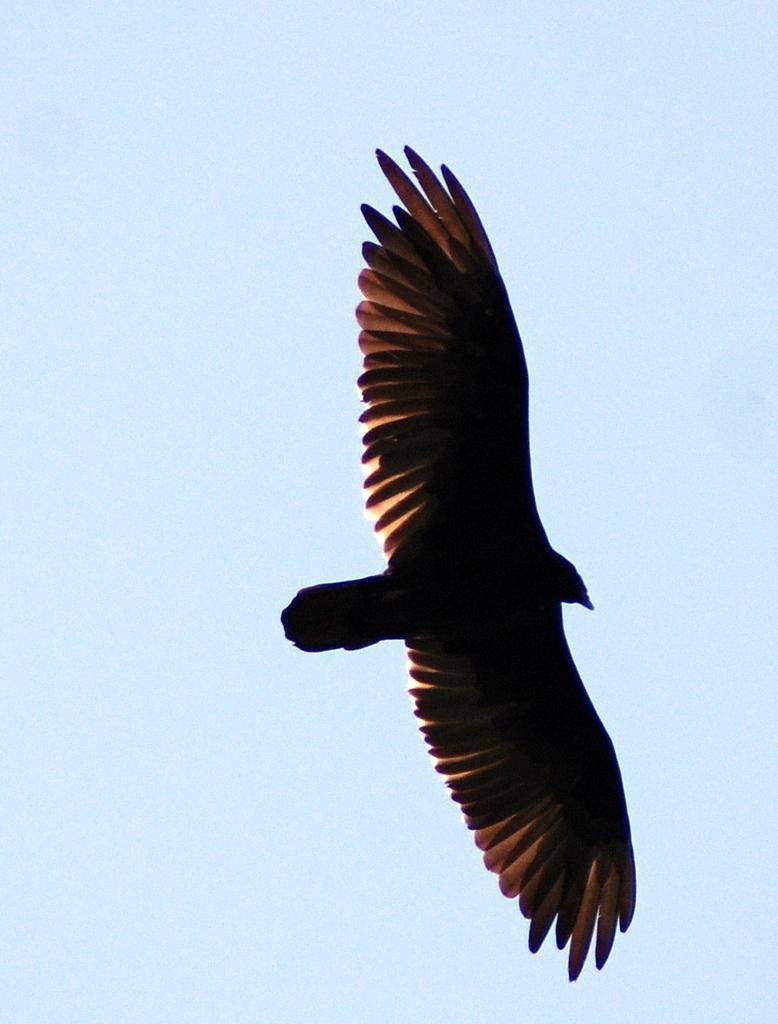What is the main subject of the image? The main subject of the image is a bird. What is the bird doing in the image? The bird is flying in the image. Where is the bird located in the image? The bird is in the sky in the image. What is the condition of the sky in the image? The sky is clear in the image. What type of design can be seen on the horse in the image? There is no horse present in the image, only a bird flying in the sky. How many men are visible in the image? There are no men visible in the image; it only features a bird flying in the sky. 